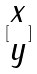<formula> <loc_0><loc_0><loc_500><loc_500>[ \begin{matrix} x \\ y \end{matrix} ]</formula> 